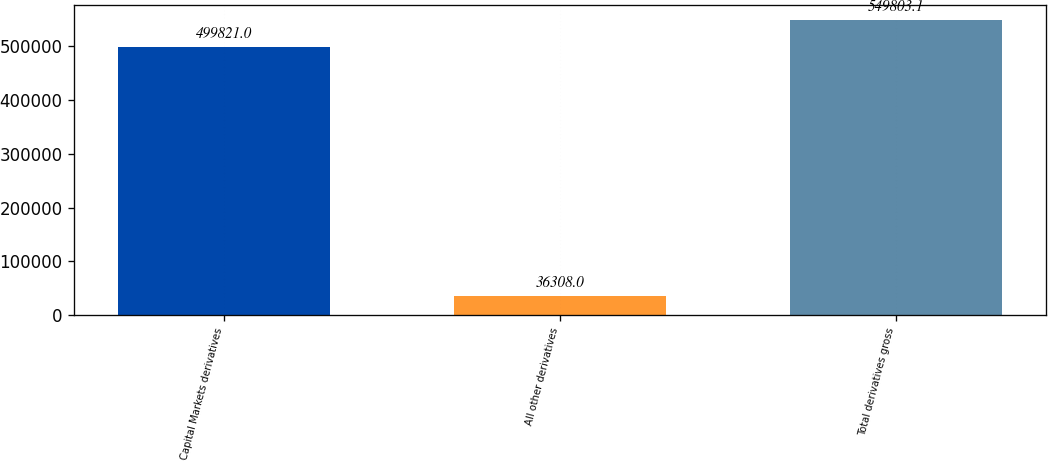Convert chart. <chart><loc_0><loc_0><loc_500><loc_500><bar_chart><fcel>Capital Markets derivatives<fcel>All other derivatives<fcel>Total derivatives gross<nl><fcel>499821<fcel>36308<fcel>549803<nl></chart> 